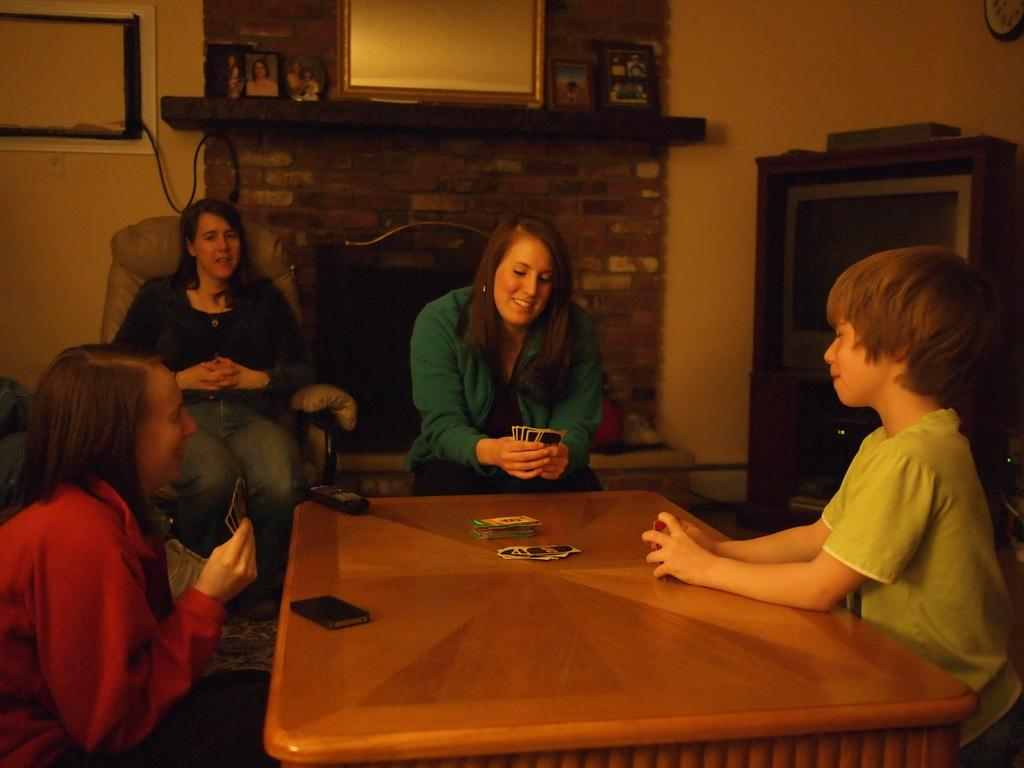How many people are seated in the image? There are four people seated on chairs in the image. What activity is the woman in the middle of the image engaged in? The woman is playing cards in the middle of the image. What objects can be seen in the background of the image? There is a mirror and a television in the background. Is the woman wearing a veil while playing cards in the image? There is no mention of a veil in the image, and the woman is not wearing one. 